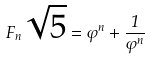Convert formula to latex. <formula><loc_0><loc_0><loc_500><loc_500>F _ { n } \sqrt { 5 } = \varphi ^ { n } + \frac { 1 } { \varphi ^ { n } }</formula> 